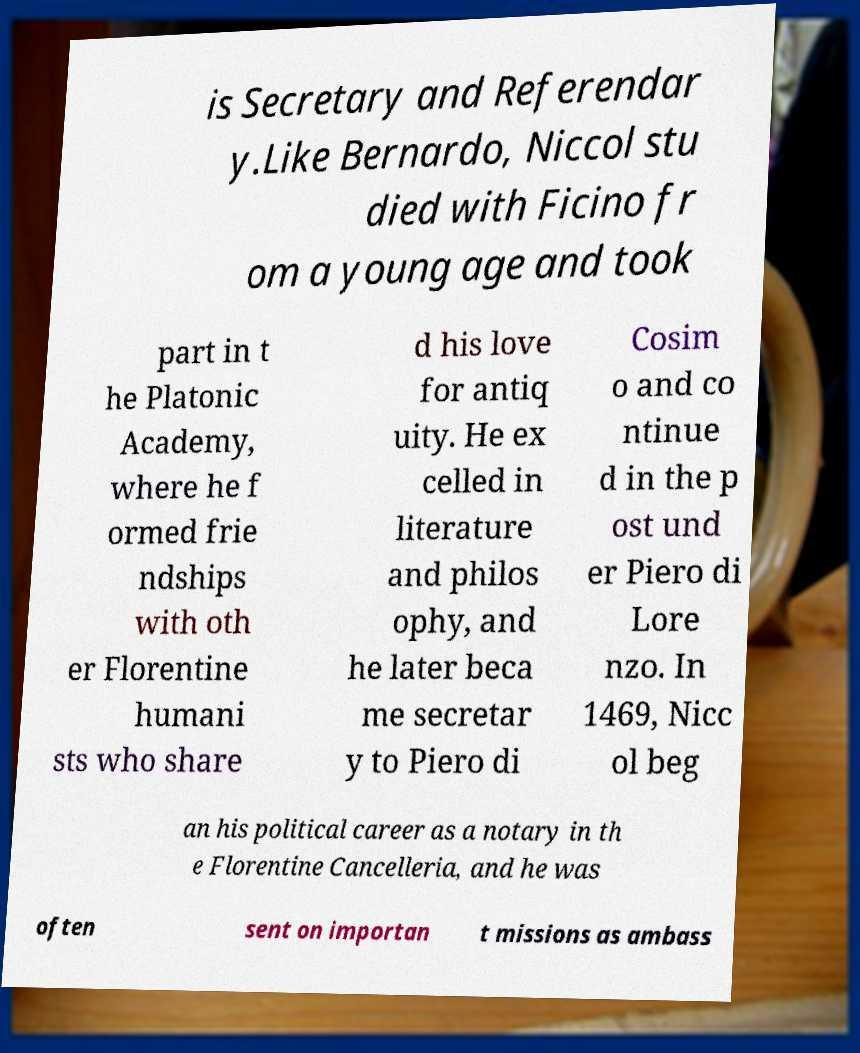Can you accurately transcribe the text from the provided image for me? is Secretary and Referendar y.Like Bernardo, Niccol stu died with Ficino fr om a young age and took part in t he Platonic Academy, where he f ormed frie ndships with oth er Florentine humani sts who share d his love for antiq uity. He ex celled in literature and philos ophy, and he later beca me secretar y to Piero di Cosim o and co ntinue d in the p ost und er Piero di Lore nzo. In 1469, Nicc ol beg an his political career as a notary in th e Florentine Cancelleria, and he was often sent on importan t missions as ambass 